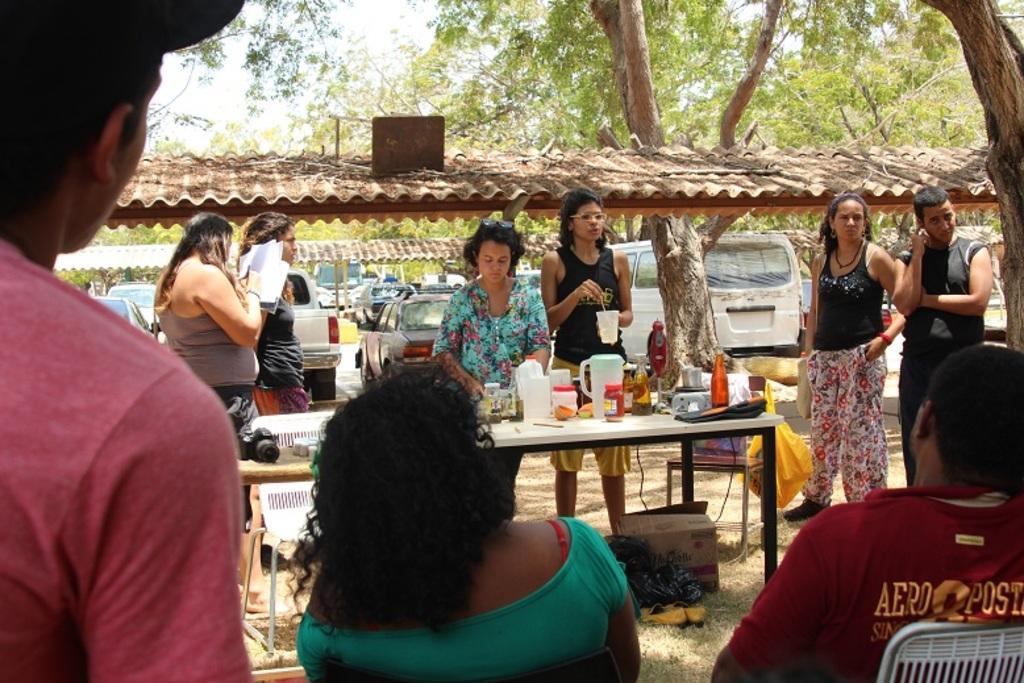Please provide a concise description of this image. in the picture there are many people standing and two people are sitting ,there are tables in front of the people in which there are many items,there are trees,there are many cars. 